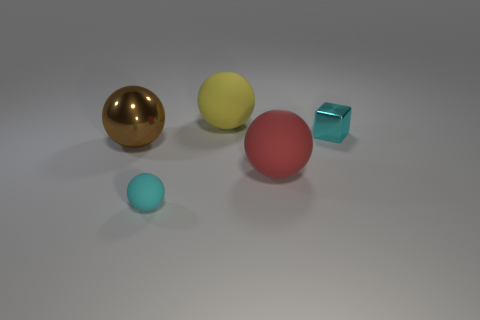Is the number of large balls less than the number of red rubber balls?
Keep it short and to the point. No. The large rubber thing that is to the left of the large ball on the right side of the ball behind the big metallic sphere is what shape?
Your answer should be very brief. Sphere. How many objects are either small things in front of the big brown shiny thing or tiny cyan objects that are behind the cyan sphere?
Offer a terse response. 2. There is a cube; are there any big brown things on the left side of it?
Offer a terse response. Yes. How many objects are large objects behind the big brown thing or big red matte spheres?
Give a very brief answer. 2. How many cyan things are either matte balls or metal objects?
Make the answer very short. 2. What number of other things are the same color as the small shiny thing?
Offer a very short reply. 1. Are there fewer metal spheres that are on the right side of the shiny ball than big spheres?
Offer a terse response. Yes. The large thing that is to the left of the rubber sphere behind the sphere to the left of the cyan rubber thing is what color?
Provide a succinct answer. Brown. Are there any other things that have the same material as the large brown ball?
Provide a short and direct response. Yes. 